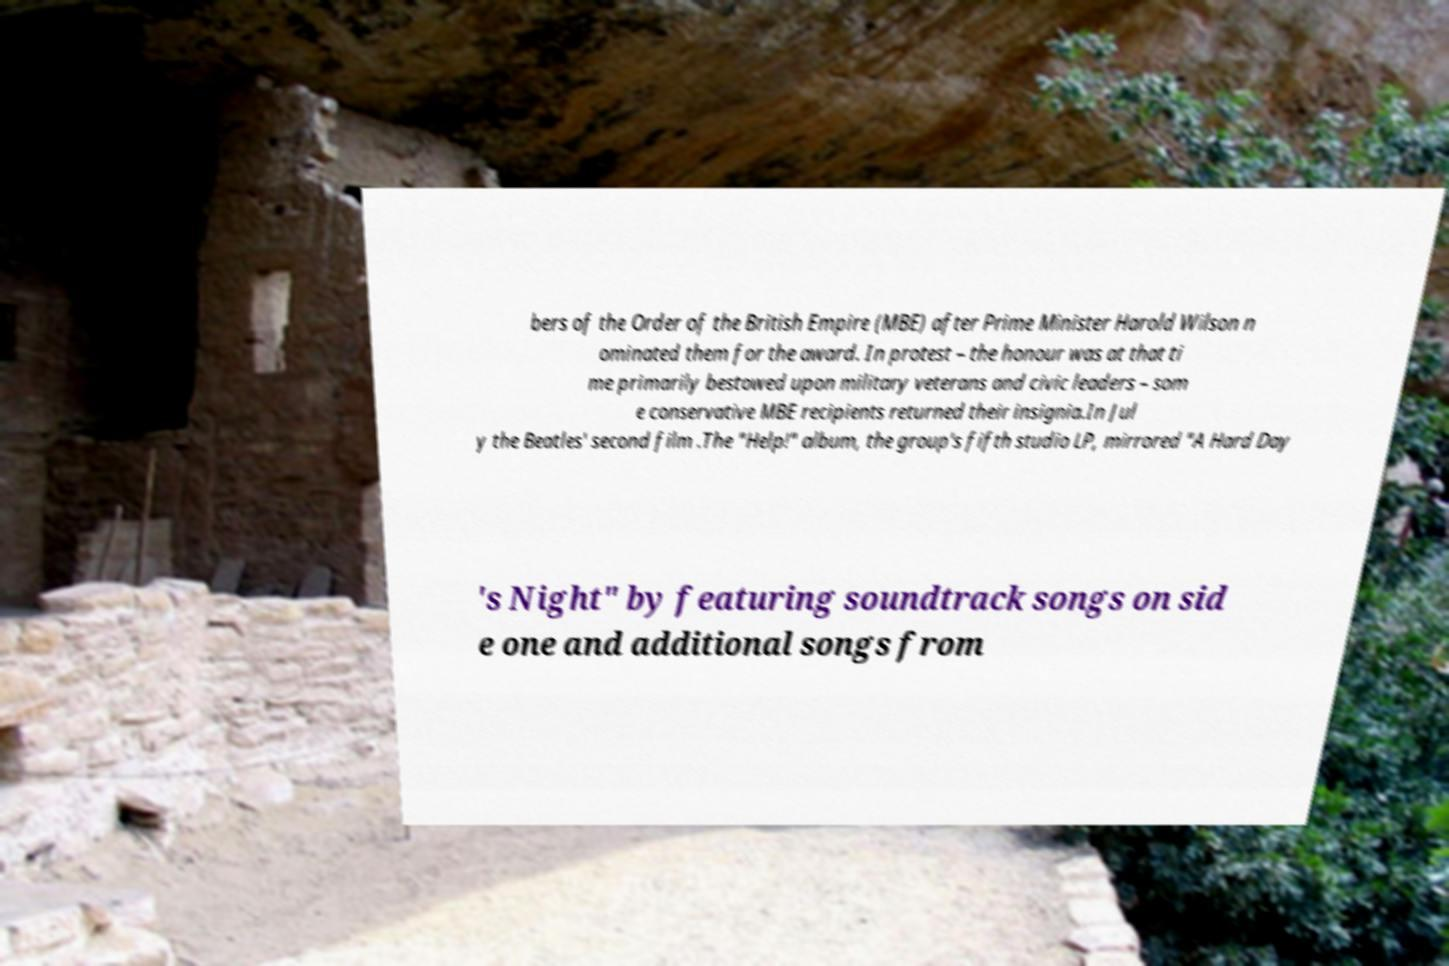Can you read and provide the text displayed in the image?This photo seems to have some interesting text. Can you extract and type it out for me? bers of the Order of the British Empire (MBE) after Prime Minister Harold Wilson n ominated them for the award. In protest – the honour was at that ti me primarily bestowed upon military veterans and civic leaders – som e conservative MBE recipients returned their insignia.In Jul y the Beatles' second film .The "Help!" album, the group's fifth studio LP, mirrored "A Hard Day 's Night" by featuring soundtrack songs on sid e one and additional songs from 